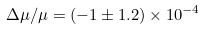Convert formula to latex. <formula><loc_0><loc_0><loc_500><loc_500>\Delta \mu / \mu = ( - 1 \pm 1 . 2 ) \times 1 0 ^ { - 4 }</formula> 